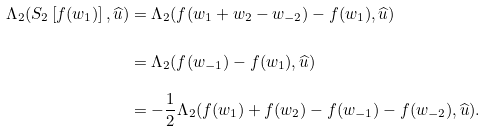Convert formula to latex. <formula><loc_0><loc_0><loc_500><loc_500>\Lambda _ { 2 } ( S _ { 2 } \left [ f ( w _ { 1 } ) \right ] , \widehat { u } ) & = \Lambda _ { 2 } ( f ( w _ { 1 } + w _ { 2 } - w _ { - 2 } ) - f ( w _ { 1 } ) , \widehat { u } ) \\ & = \Lambda _ { 2 } ( f ( w _ { - 1 } ) - f ( w _ { 1 } ) , \widehat { u } ) \\ & = - \frac { 1 } { 2 } \Lambda _ { 2 } ( f ( w _ { 1 } ) + f ( w _ { 2 } ) - f ( w _ { - 1 } ) - f ( w _ { - 2 } ) , \widehat { u } ) .</formula> 